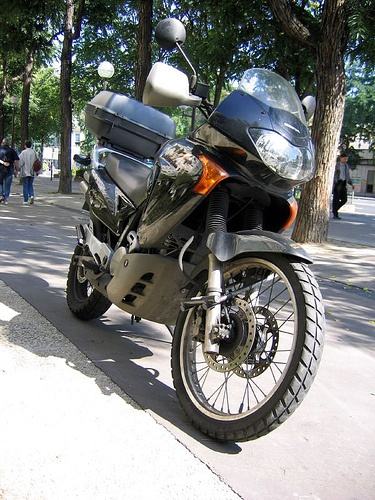Describe the objects in this image and their specific colors. I can see motorcycle in black, gray, white, and darkgray tones, people in black and gray tones, people in black, darkgray, navy, and gray tones, people in black, navy, gray, and darkblue tones, and handbag in black, gray, and purple tones in this image. 